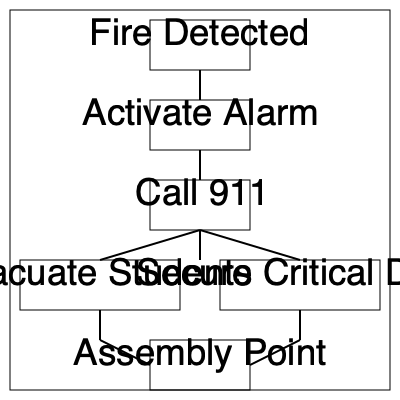In the given flow chart of the school's emergency evacuation procedure, which critical step should be performed immediately after activating the alarm system? To answer this question, let's analyze the flow chart step-by-step:

1. The procedure starts with "Fire Detected" at the top of the chart.
2. The next step is "Activate Alarm," which is crucial for alerting everyone in the school about the emergency.
3. Immediately following the "Activate Alarm" step, we see a single arrow pointing to the next action: "Call 911."
4. After calling 911, the flow chart branches into two parallel actions: "Evacuate Students" and "Secure Critical Data."
5. Both of these actions then lead to the final step: "Assembly Point."

The question asks about the critical step immediately after activating the alarm system. Based on the flow chart, the step that directly follows "Activate Alarm" is "Call 911." This is a crucial step in any emergency procedure, as it ensures that professional emergency responders are notified and can be dispatched to the school as quickly as possible.

Calling 911 before proceeding with evacuation and securing data is essential because:
1. It minimizes response time for emergency services.
2. It allows for professional guidance if needed during the evacuation process.
3. It ensures that help is on the way while school staff focus on safely evacuating students and securing critical information.

Therefore, the critical step that should be performed immediately after activating the alarm system is calling 911.
Answer: Call 911 